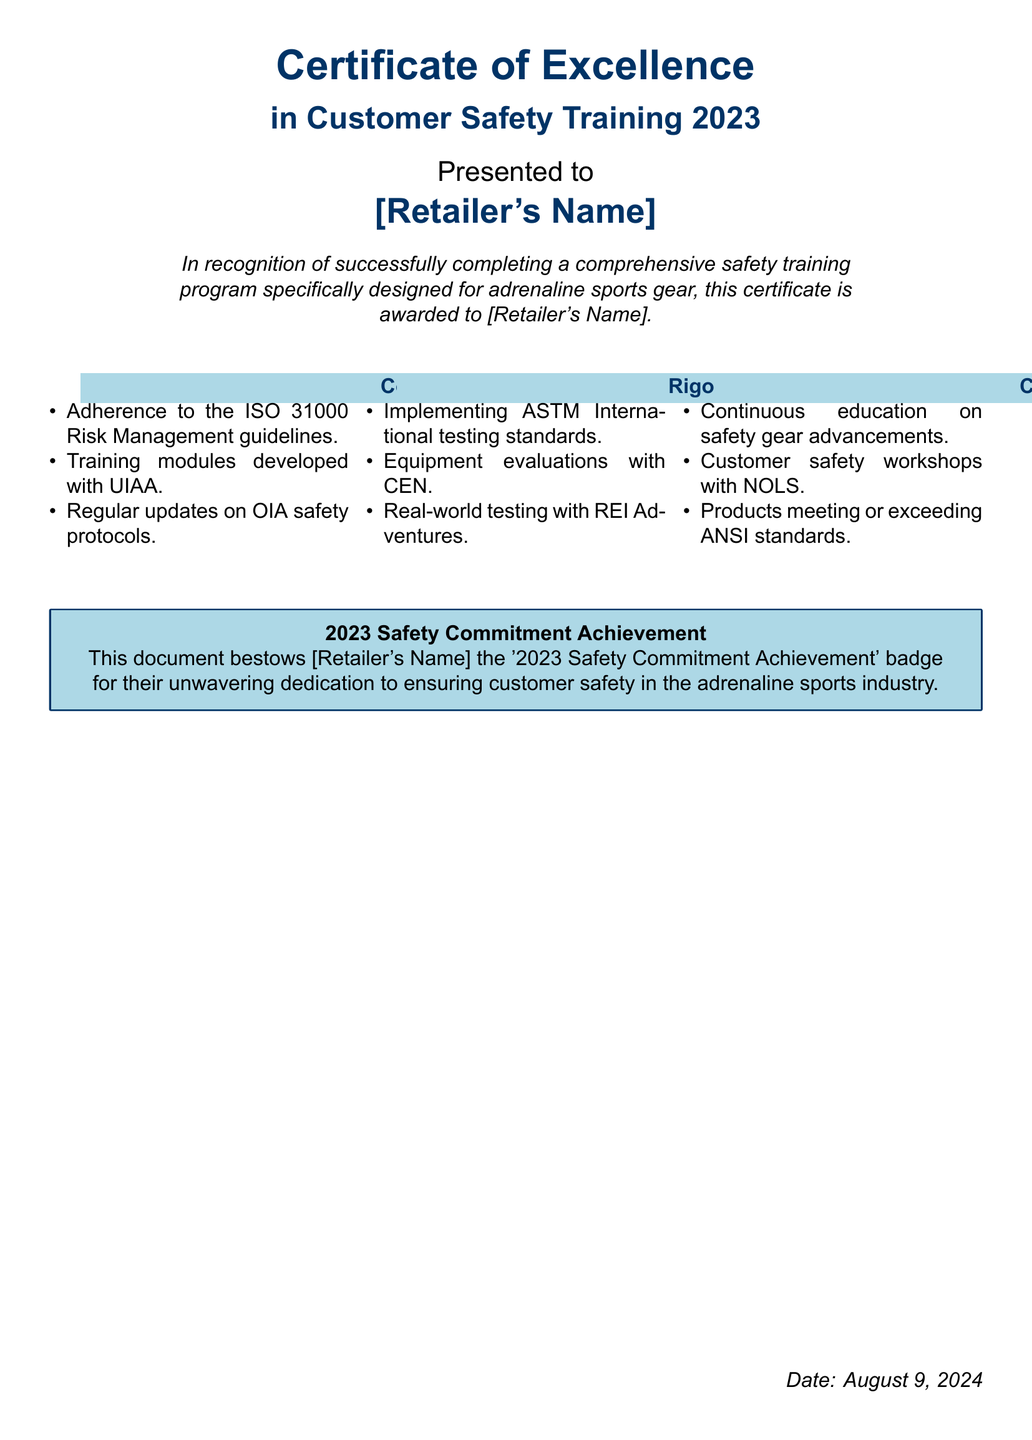What is the title of the certificate? The title of the certificate is presented prominently at the top of the document as "Certificate of Excellence in Customer Safety Training 2023".
Answer: Certificate of Excellence in Customer Safety Training 2023 Who is the certificate presented to? The recipient of the certificate is specified in the document as "[Retailer's Name]".
Answer: [Retailer's Name] What specific training program does the certificate recognize? The certificate recognizes a "comprehensive safety training program specifically designed for adrenaline sports gear".
Answer: comprehensive safety training program for adrenaline sports gear What standard do the training modules adhere to? The training modules included in the program adhere to "ISO 31000 Risk Management guidelines".
Answer: ISO 31000 Risk Management guidelines What is the date mentioned on the certificate? The date on the certificate is indicated at the bottom as “\today”, which represents the current date.
Answer: today What badge is awarded to the retailer? The document specifies the award of the "2023 Safety Commitment Achievement" badge.
Answer: 2023 Safety Commitment Achievement Which organization collaborates for customer safety workshops? The document mentions that customer safety workshops are conducted in collaboration with "NOLS".
Answer: NOLS What testing standards are implemented according to the document? The document states that "ASTM International testing standards" are implemented.
Answer: ASTM International testing standards What is emphasized in the “Rigorous Testing and Safety Assurance” section? This section emphasizes "Implementing ASTM International testing standards" among other practices.
Answer: Implementing ASTM International testing standards 